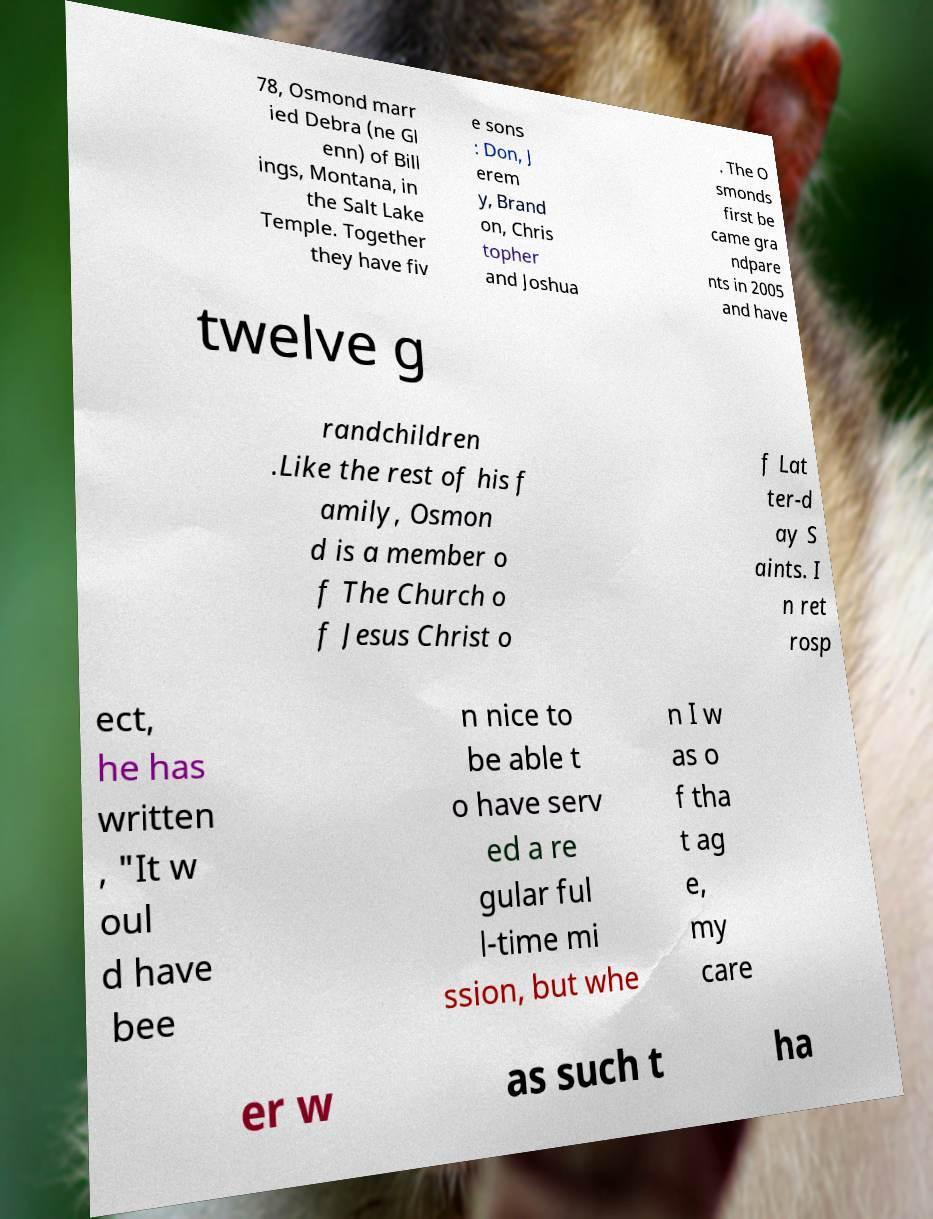Could you assist in decoding the text presented in this image and type it out clearly? 78, Osmond marr ied Debra (ne Gl enn) of Bill ings, Montana, in the Salt Lake Temple. Together they have fiv e sons : Don, J erem y, Brand on, Chris topher and Joshua . The O smonds first be came gra ndpare nts in 2005 and have twelve g randchildren .Like the rest of his f amily, Osmon d is a member o f The Church o f Jesus Christ o f Lat ter-d ay S aints. I n ret rosp ect, he has written , "It w oul d have bee n nice to be able t o have serv ed a re gular ful l-time mi ssion, but whe n I w as o f tha t ag e, my care er w as such t ha 